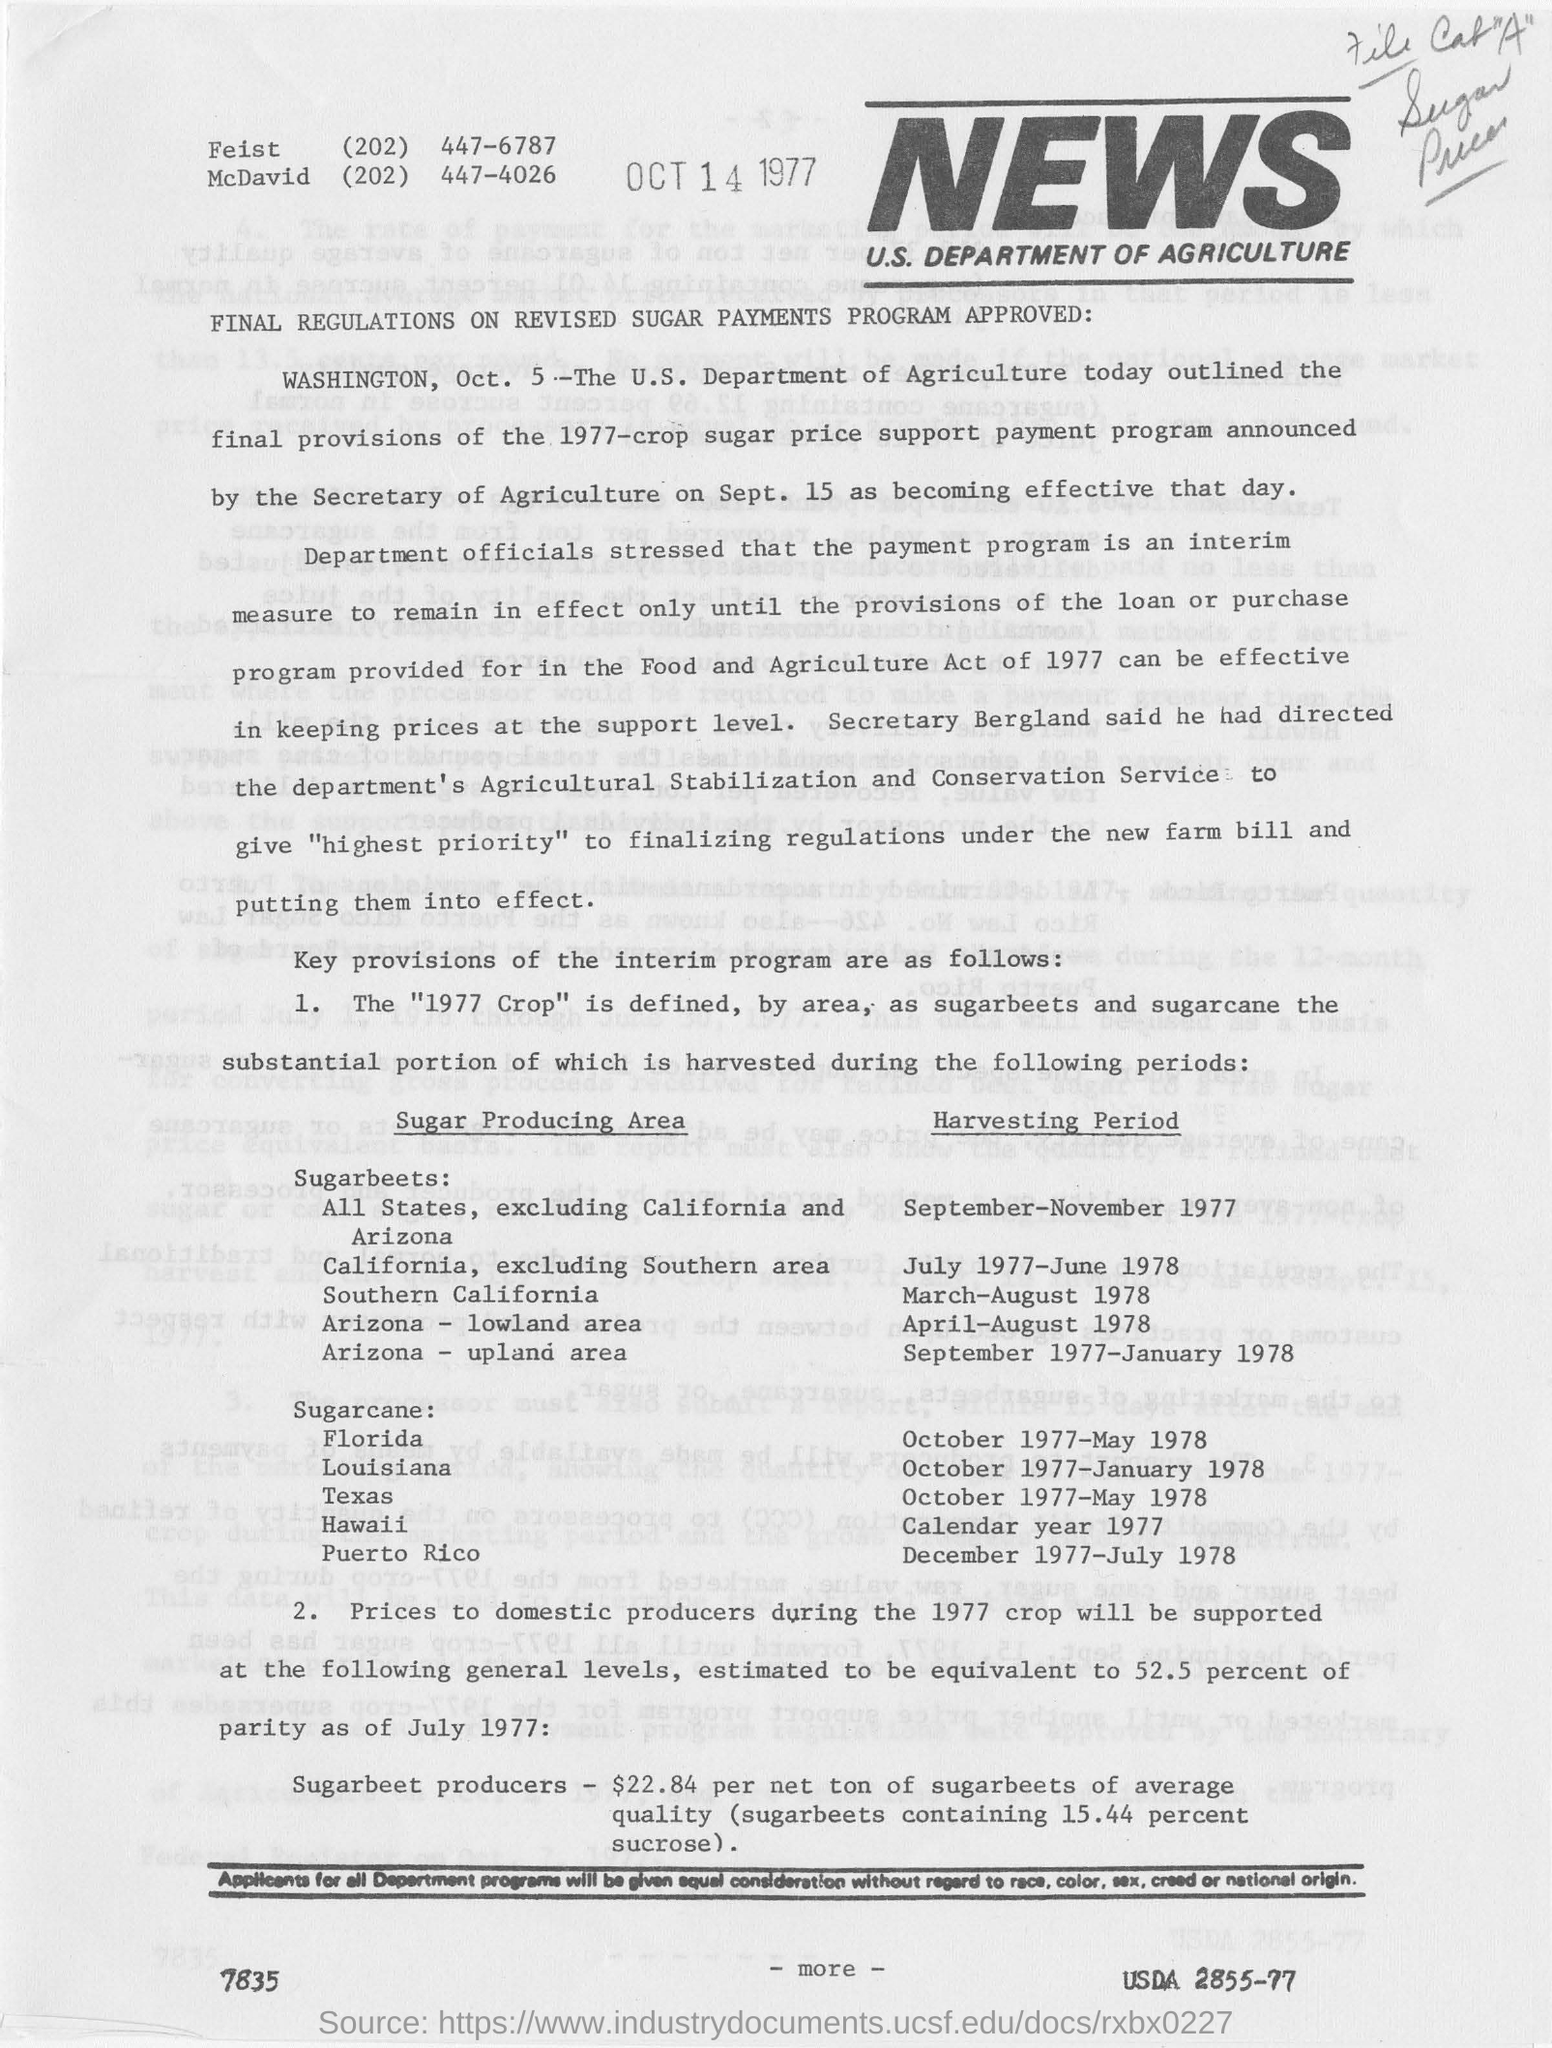Who outlined the final provisions of 1977-crop sugar price support payment program?
Your answer should be compact. The u.s. department of agriculture. 